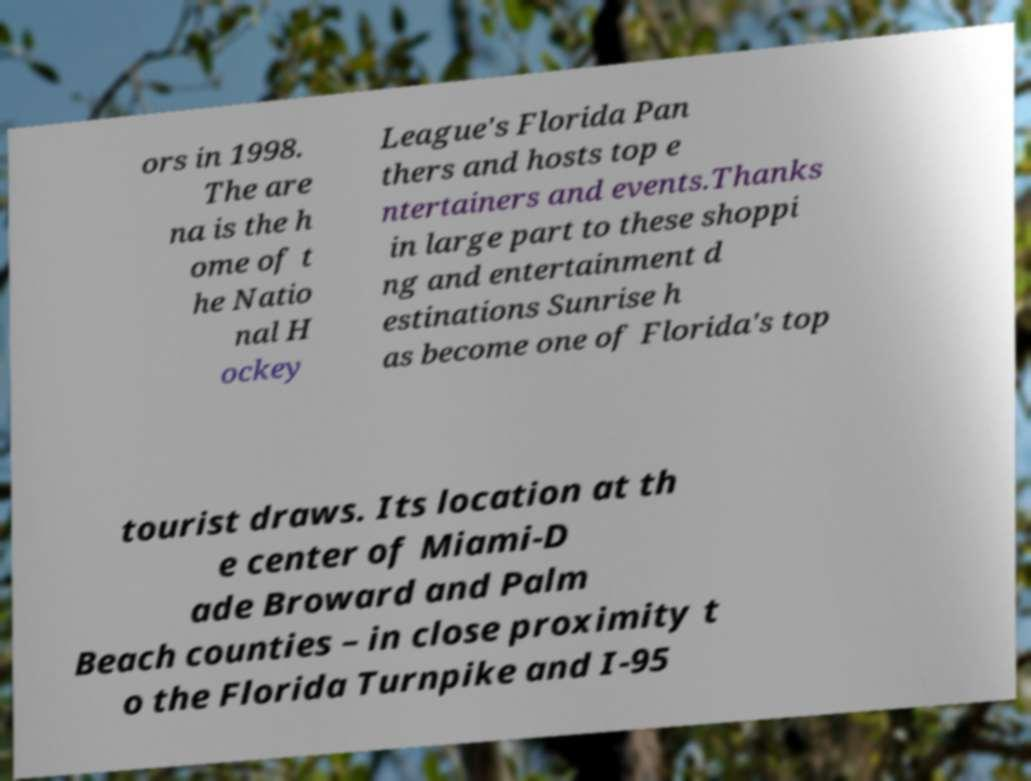Can you accurately transcribe the text from the provided image for me? ors in 1998. The are na is the h ome of t he Natio nal H ockey League's Florida Pan thers and hosts top e ntertainers and events.Thanks in large part to these shoppi ng and entertainment d estinations Sunrise h as become one of Florida's top tourist draws. Its location at th e center of Miami-D ade Broward and Palm Beach counties – in close proximity t o the Florida Turnpike and I-95 